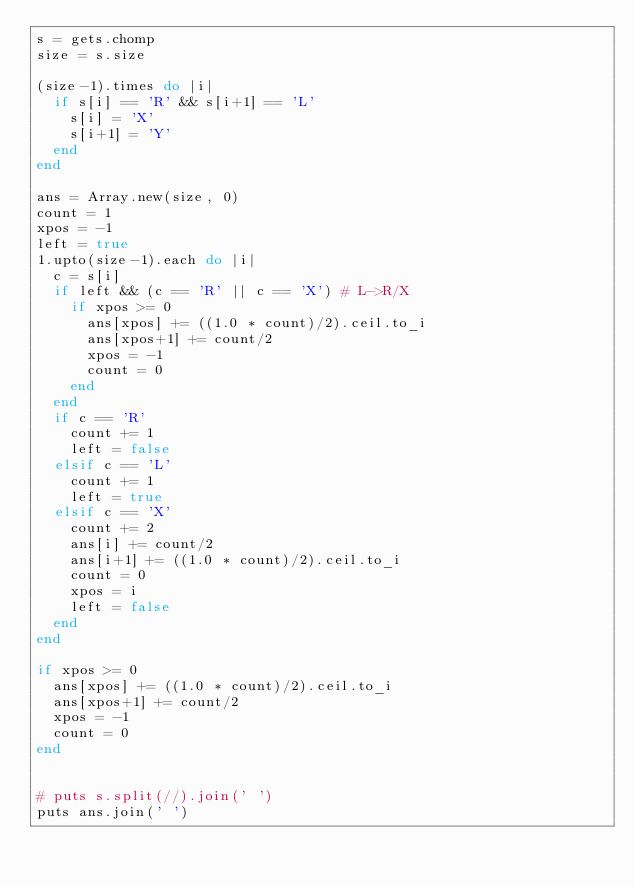Convert code to text. <code><loc_0><loc_0><loc_500><loc_500><_Ruby_>s = gets.chomp
size = s.size

(size-1).times do |i|
  if s[i] == 'R' && s[i+1] == 'L'
    s[i] = 'X'
    s[i+1] = 'Y'
  end
end

ans = Array.new(size, 0)
count = 1
xpos = -1
left = true
1.upto(size-1).each do |i|
  c = s[i]
  if left && (c == 'R' || c == 'X') # L->R/X
    if xpos >= 0
      ans[xpos] += ((1.0 * count)/2).ceil.to_i
      ans[xpos+1] += count/2
      xpos = -1
      count = 0
    end
  end
  if c == 'R'
    count += 1
    left = false
  elsif c == 'L'
    count += 1
    left = true
  elsif c == 'X'
    count += 2
    ans[i] += count/2
    ans[i+1] += ((1.0 * count)/2).ceil.to_i
    count = 0
    xpos = i
    left = false
  end
end

if xpos >= 0
  ans[xpos] += ((1.0 * count)/2).ceil.to_i
  ans[xpos+1] += count/2
  xpos = -1
  count = 0
end


# puts s.split(//).join(' ')
puts ans.join(' ')
</code> 